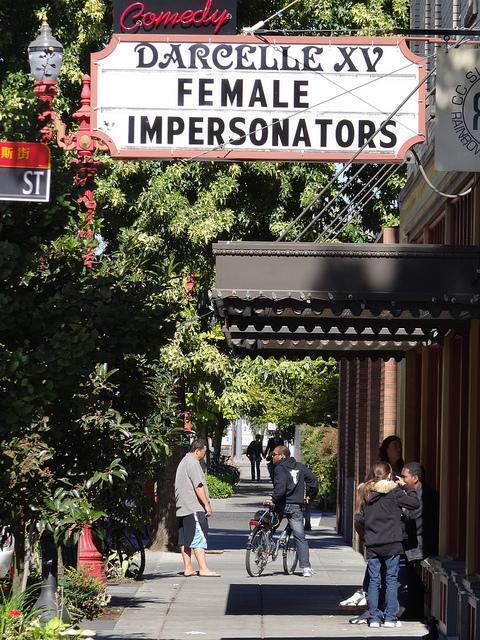Why do they impersonate females?
Select the accurate response from the four choices given to answer the question.
Options: Avoid police, confused, disguise, money. Money. 